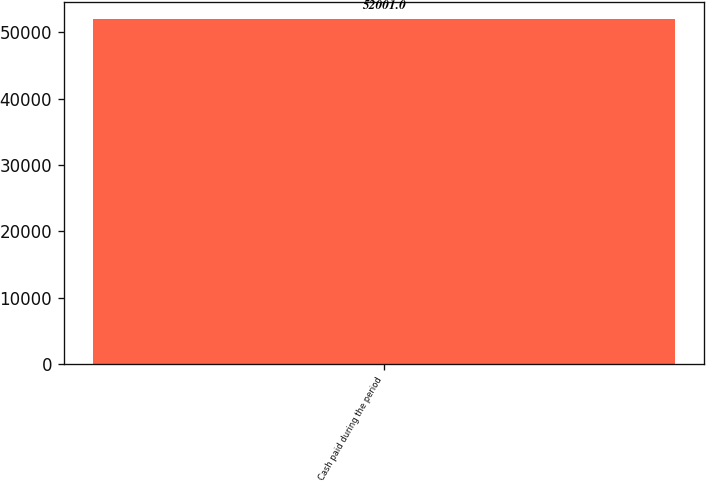<chart> <loc_0><loc_0><loc_500><loc_500><bar_chart><fcel>Cash paid during the period<nl><fcel>52001<nl></chart> 